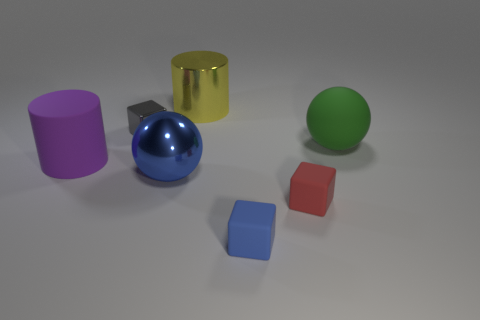Subtract all blue cubes. How many cubes are left? 2 Subtract all purple cylinders. How many cylinders are left? 1 Add 2 tiny blue objects. How many objects exist? 9 Subtract 1 cubes. How many cubes are left? 2 Subtract all green cylinders. Subtract all green balls. How many cylinders are left? 2 Subtract all cylinders. How many objects are left? 5 Subtract all gray balls. How many yellow cylinders are left? 1 Subtract all blue matte blocks. Subtract all big green matte things. How many objects are left? 5 Add 3 purple matte cylinders. How many purple matte cylinders are left? 4 Add 3 brown shiny blocks. How many brown shiny blocks exist? 3 